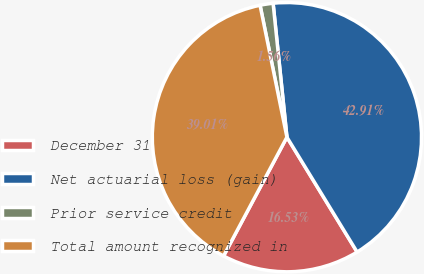<chart> <loc_0><loc_0><loc_500><loc_500><pie_chart><fcel>December 31<fcel>Net actuarial loss (gain)<fcel>Prior service credit<fcel>Total amount recognized in<nl><fcel>16.53%<fcel>42.91%<fcel>1.56%<fcel>39.01%<nl></chart> 